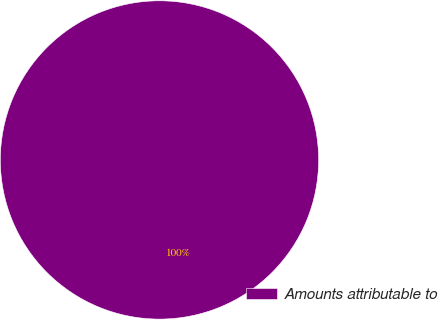<chart> <loc_0><loc_0><loc_500><loc_500><pie_chart><fcel>Amounts attributable to<nl><fcel>100.0%<nl></chart> 